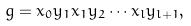Convert formula to latex. <formula><loc_0><loc_0><loc_500><loc_500>g = x _ { 0 } y _ { 1 } x _ { 1 } y _ { 2 } \cdots x _ { l } y _ { l + 1 } ,</formula> 